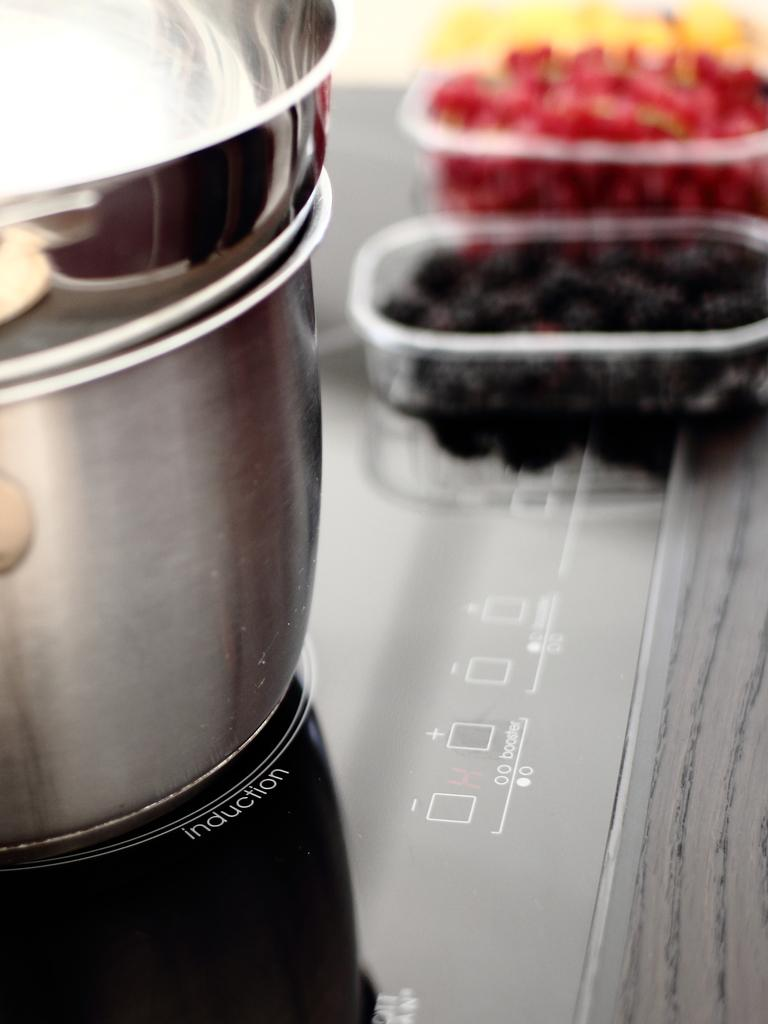What is the main object in the image? There is an induction base in the image. What is placed on the induction base? There is a vessel on the induction base. What else can be seen on the induction base? There are fruits in disposal containers on the induction base. What type of clouds can be seen in the image? There are no clouds present in the image; it features an induction base with a vessel and fruits in disposal containers. Are there any bells ringing in the image? There are no bells present in the image. 